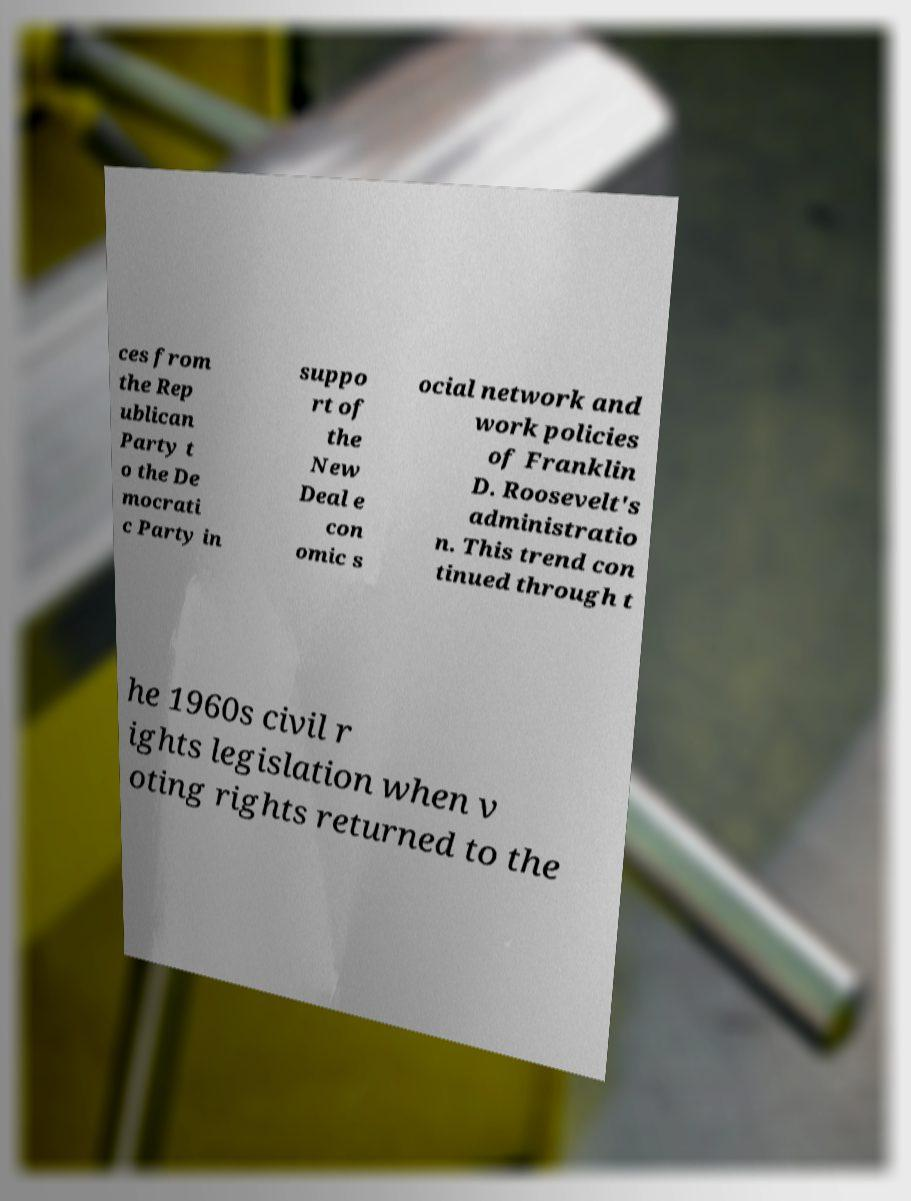Please read and relay the text visible in this image. What does it say? ces from the Rep ublican Party t o the De mocrati c Party in suppo rt of the New Deal e con omic s ocial network and work policies of Franklin D. Roosevelt's administratio n. This trend con tinued through t he 1960s civil r ights legislation when v oting rights returned to the 